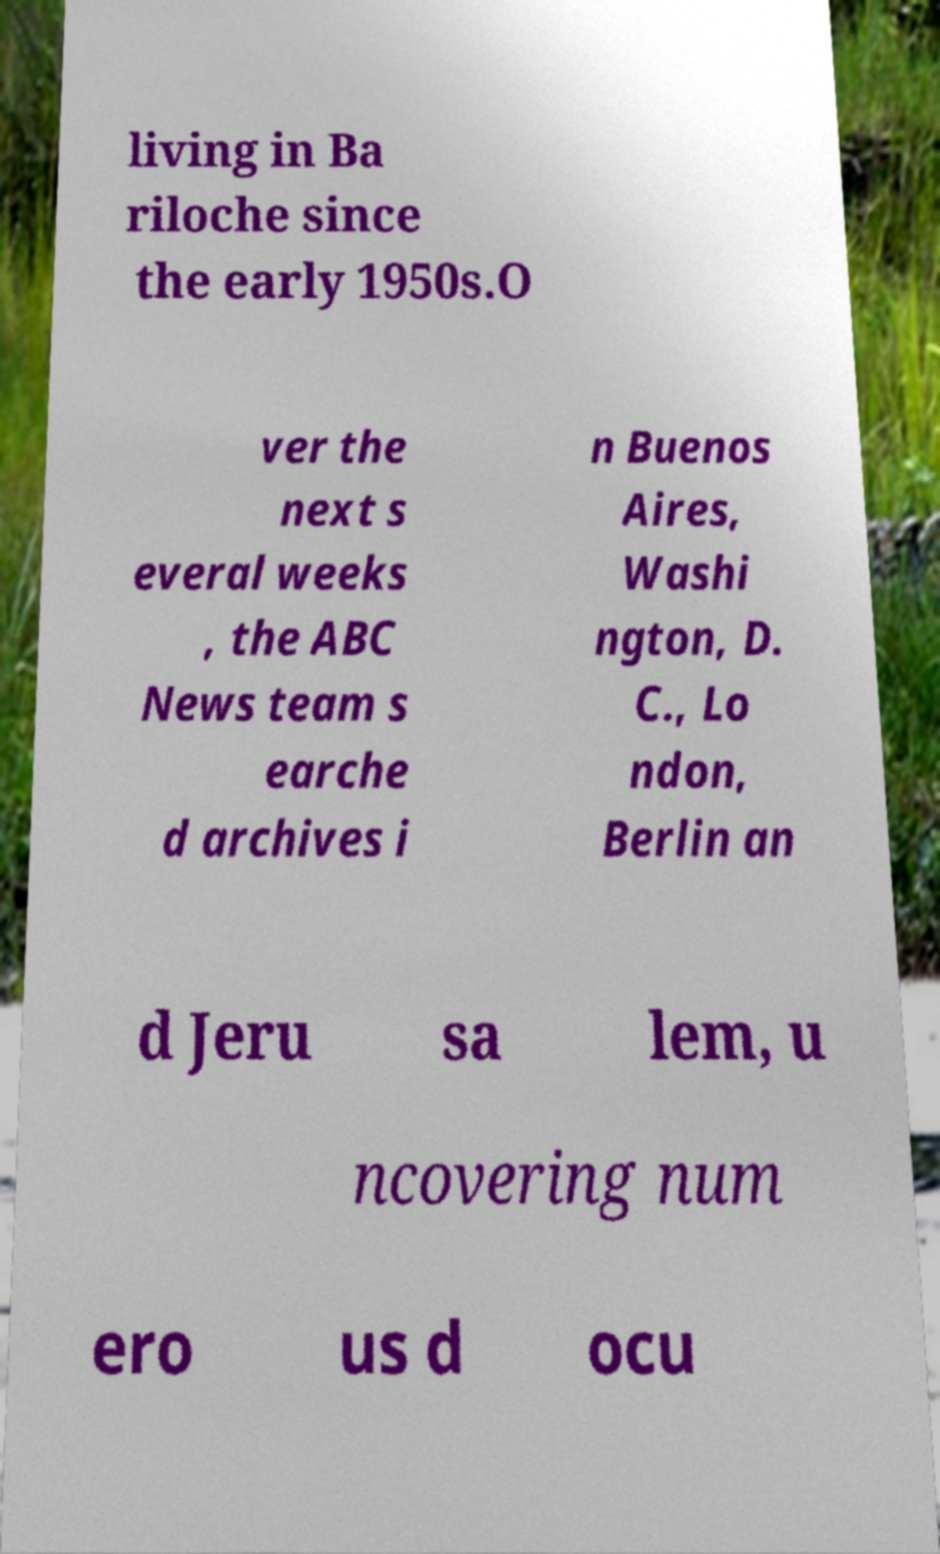Could you extract and type out the text from this image? living in Ba riloche since the early 1950s.O ver the next s everal weeks , the ABC News team s earche d archives i n Buenos Aires, Washi ngton, D. C., Lo ndon, Berlin an d Jeru sa lem, u ncovering num ero us d ocu 